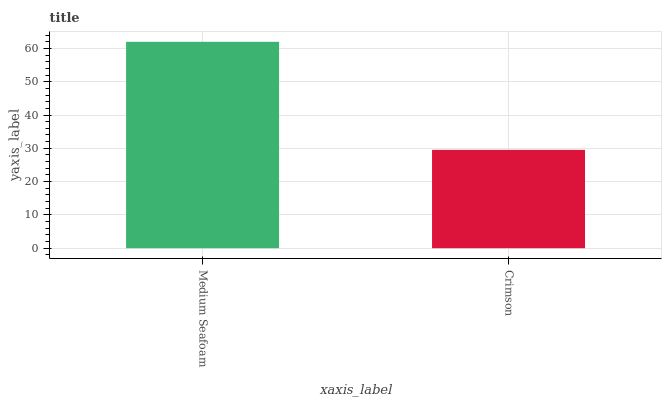Is Crimson the minimum?
Answer yes or no. Yes. Is Medium Seafoam the maximum?
Answer yes or no. Yes. Is Crimson the maximum?
Answer yes or no. No. Is Medium Seafoam greater than Crimson?
Answer yes or no. Yes. Is Crimson less than Medium Seafoam?
Answer yes or no. Yes. Is Crimson greater than Medium Seafoam?
Answer yes or no. No. Is Medium Seafoam less than Crimson?
Answer yes or no. No. Is Medium Seafoam the high median?
Answer yes or no. Yes. Is Crimson the low median?
Answer yes or no. Yes. Is Crimson the high median?
Answer yes or no. No. Is Medium Seafoam the low median?
Answer yes or no. No. 